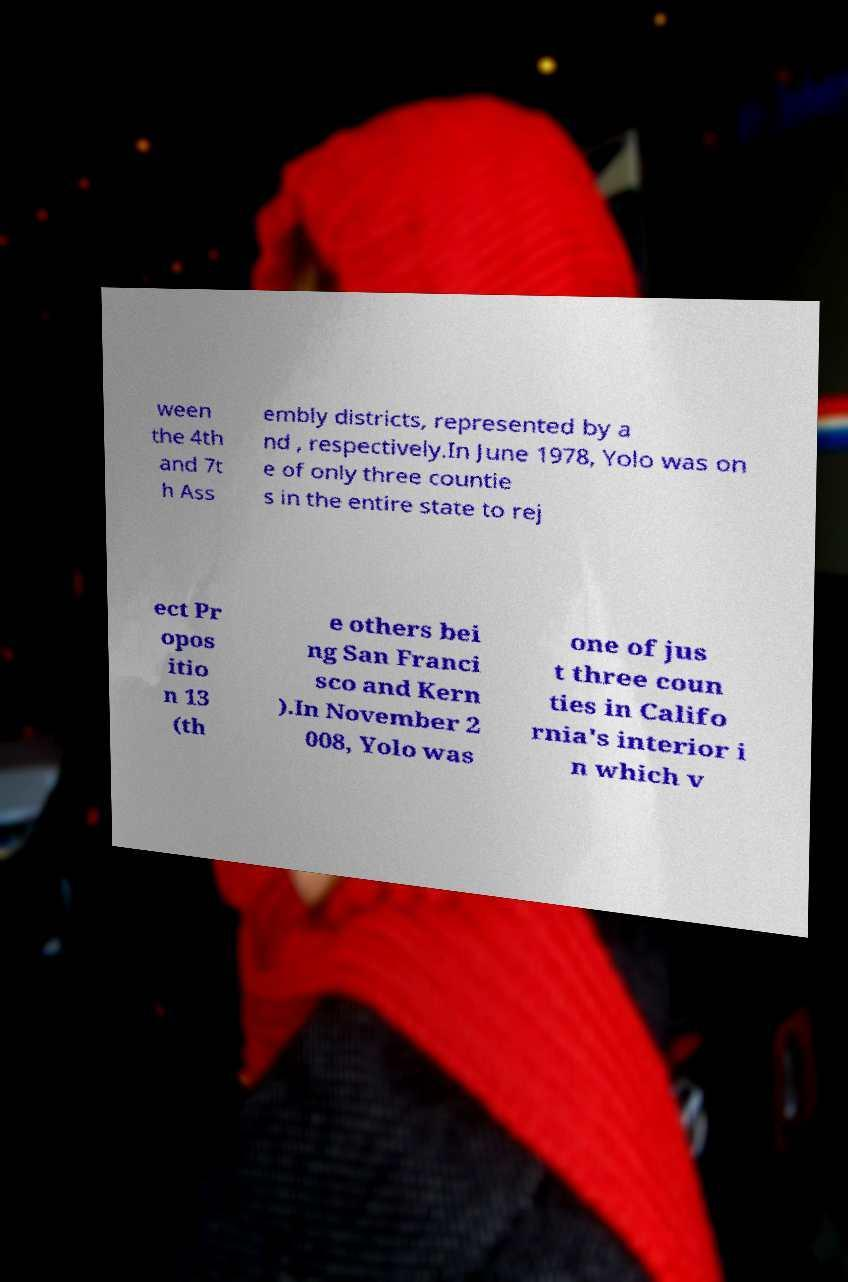Please read and relay the text visible in this image. What does it say? ween the 4th and 7t h Ass embly districts, represented by a nd , respectively.In June 1978, Yolo was on e of only three countie s in the entire state to rej ect Pr opos itio n 13 (th e others bei ng San Franci sco and Kern ).In November 2 008, Yolo was one of jus t three coun ties in Califo rnia's interior i n which v 